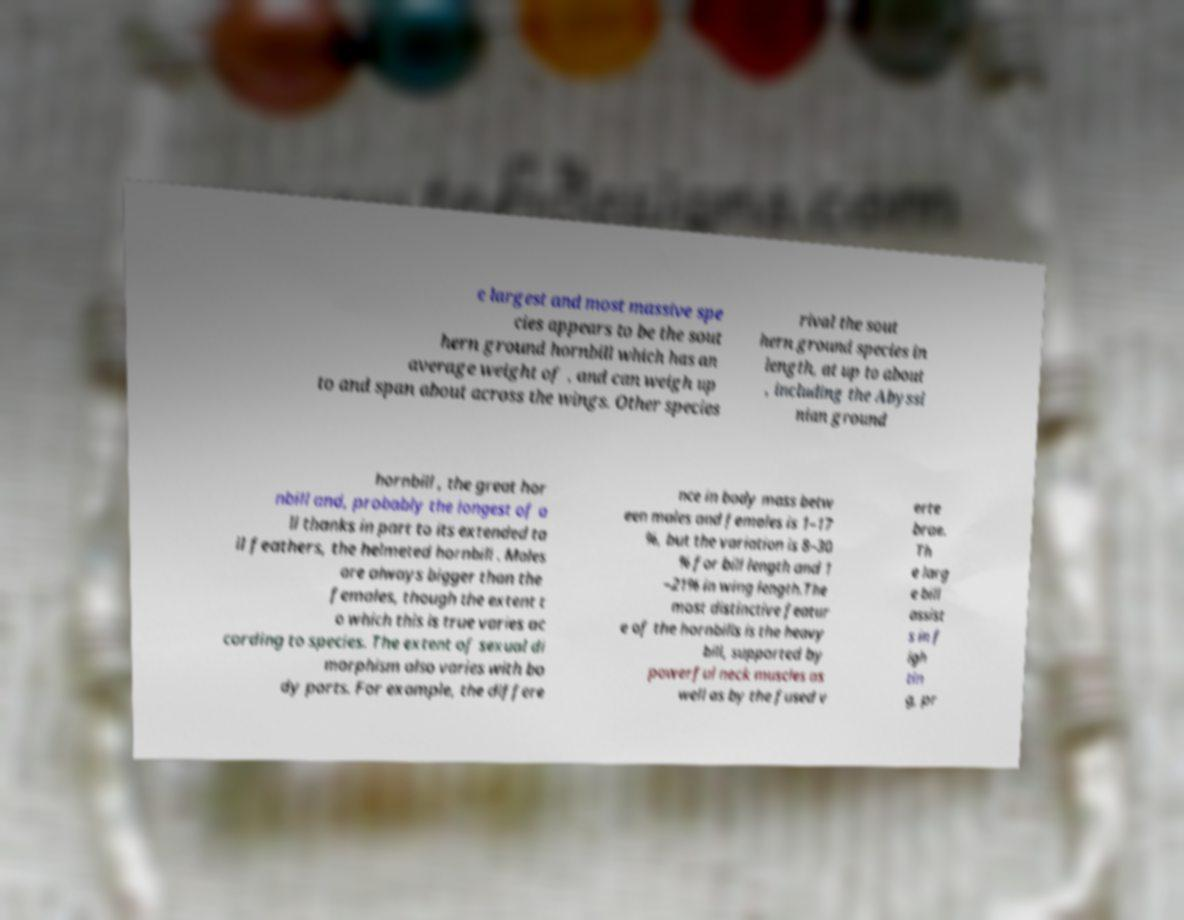Please identify and transcribe the text found in this image. e largest and most massive spe cies appears to be the sout hern ground hornbill which has an average weight of , and can weigh up to and span about across the wings. Other species rival the sout hern ground species in length, at up to about , including the Abyssi nian ground hornbill , the great hor nbill and, probably the longest of a ll thanks in part to its extended ta il feathers, the helmeted hornbill . Males are always bigger than the females, though the extent t o which this is true varies ac cording to species. The extent of sexual di morphism also varies with bo dy parts. For example, the differe nce in body mass betw een males and females is 1–17 %, but the variation is 8–30 % for bill length and 1 –21% in wing length.The most distinctive featur e of the hornbills is the heavy bill, supported by powerful neck muscles as well as by the fused v erte brae. Th e larg e bill assist s in f igh tin g, pr 